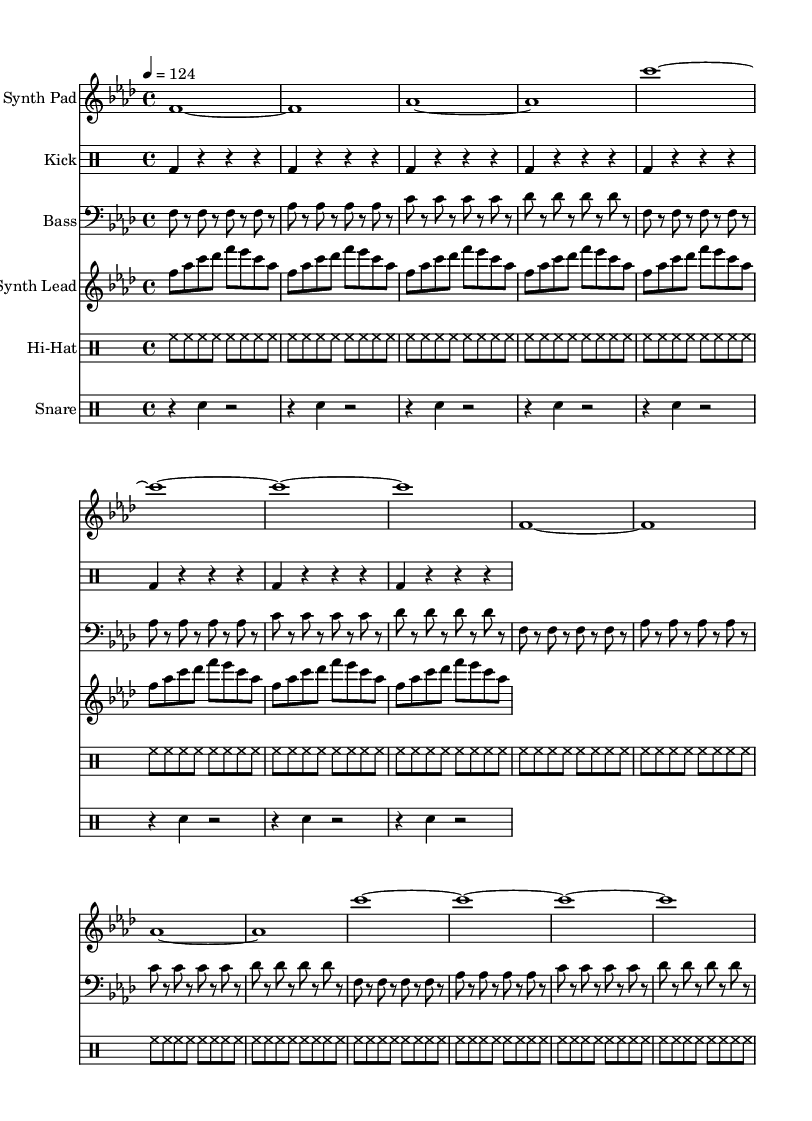What is the key signature of this music? The key signature is indicated after the word "key" in the global section. Here, it is specified as F minor, which has four flats.
Answer: F minor What is the time signature of this piece? The time signature is found next to the word "time" in the global section. It is noted as 4/4, which means there are four beats in each measure.
Answer: 4/4 What is the tempo marking of the piece? The tempo is indicated in the global section as "4 = 124," meaning the quarter note is set to 124 beats per minute.
Answer: 124 How many repetitions do the kick drum and hi-hat patterns have? The kick drum repeats eight times, as indicated by the "\repeat unfold 8" directive. The hi-hat also has the same repetition pattern with "\repeat unfold 16," meaning it has sixteens repetitions.
Answer: Kick drum: 8, Hi-hat: 16 What is the texture of the synth lead melody played in this composition? The synth lead section contains a repeating series of notes signifying a melody. It alternates between notes F, A-flat, C, D-flat, E-flat, C, and A-flat, creating a layered melodic texture integrated within the house track's structure.
Answer: Layered melody What is the main rhythmic feature present in the bassline? The bassline features a consistent rhythmic pattern that alternates between played notes and rests. Each note is played in an eighth-note rhythm with a rest following. This gives the piece a driving, danceable feeling typical of house music.
Answer: Eighth-note rhythm What is the overall style of the track based on its instrumentation? The use of synth pads, a steady kick drum, and melodic elements such as a bass and lead synth characterizes this track as deep house, which emphasizes atmospheric textures and rhythmic grooves.
Answer: Deep house 